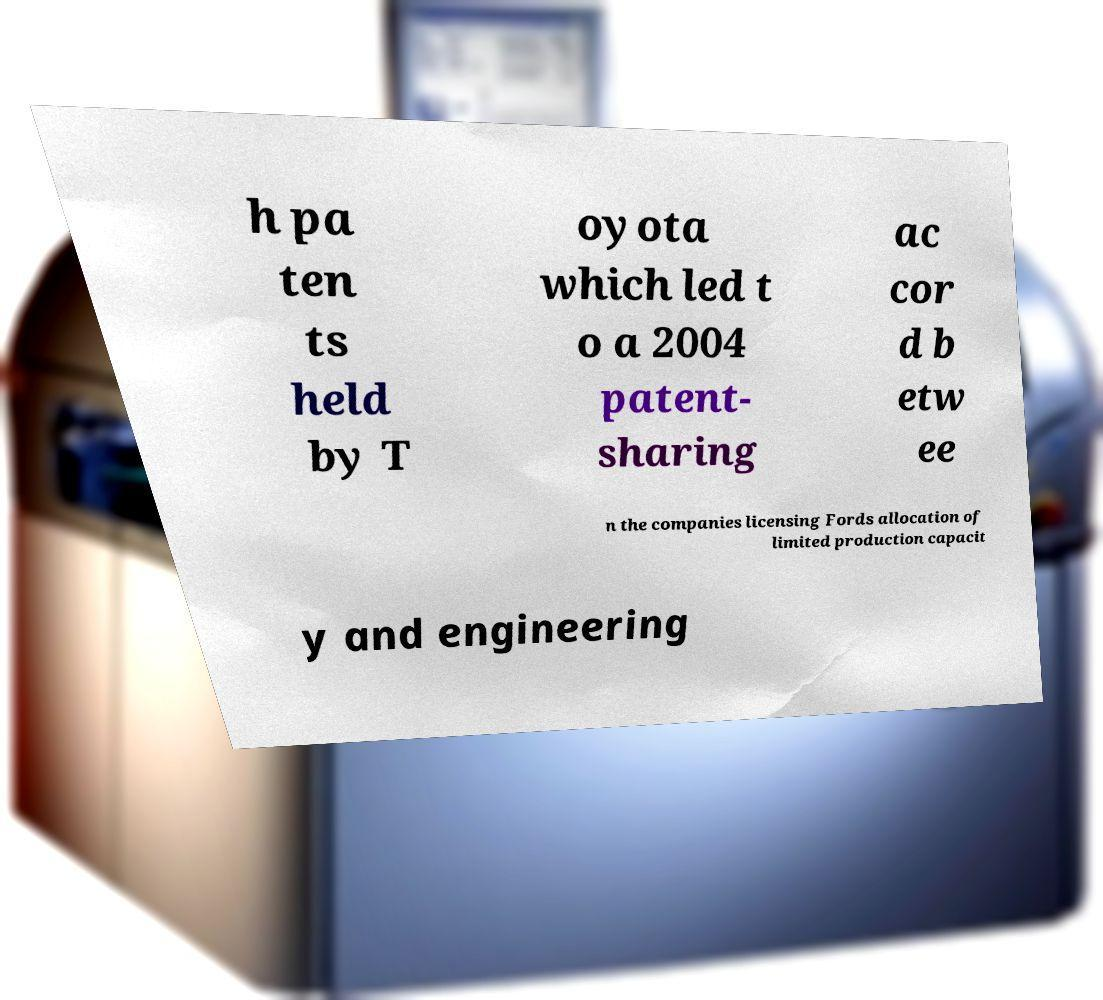For documentation purposes, I need the text within this image transcribed. Could you provide that? h pa ten ts held by T oyota which led t o a 2004 patent- sharing ac cor d b etw ee n the companies licensing Fords allocation of limited production capacit y and engineering 